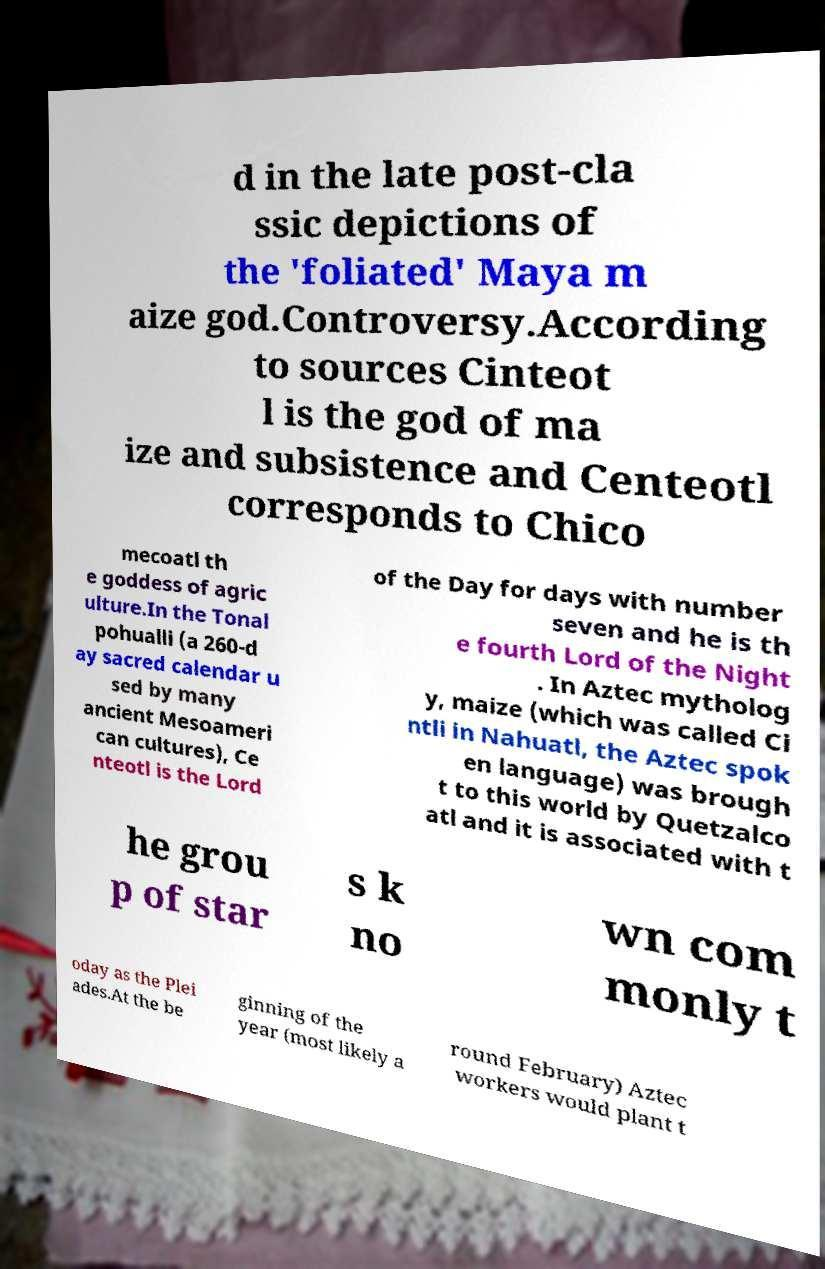Can you read and provide the text displayed in the image?This photo seems to have some interesting text. Can you extract and type it out for me? d in the late post-cla ssic depictions of the 'foliated' Maya m aize god.Controversy.According to sources Cinteot l is the god of ma ize and subsistence and Centeotl corresponds to Chico mecoatl th e goddess of agric ulture.In the Tonal pohualli (a 260-d ay sacred calendar u sed by many ancient Mesoameri can cultures), Ce nteotl is the Lord of the Day for days with number seven and he is th e fourth Lord of the Night . In Aztec mytholog y, maize (which was called Ci ntli in Nahuatl, the Aztec spok en language) was brough t to this world by Quetzalco atl and it is associated with t he grou p of star s k no wn com monly t oday as the Plei ades.At the be ginning of the year (most likely a round February) Aztec workers would plant t 